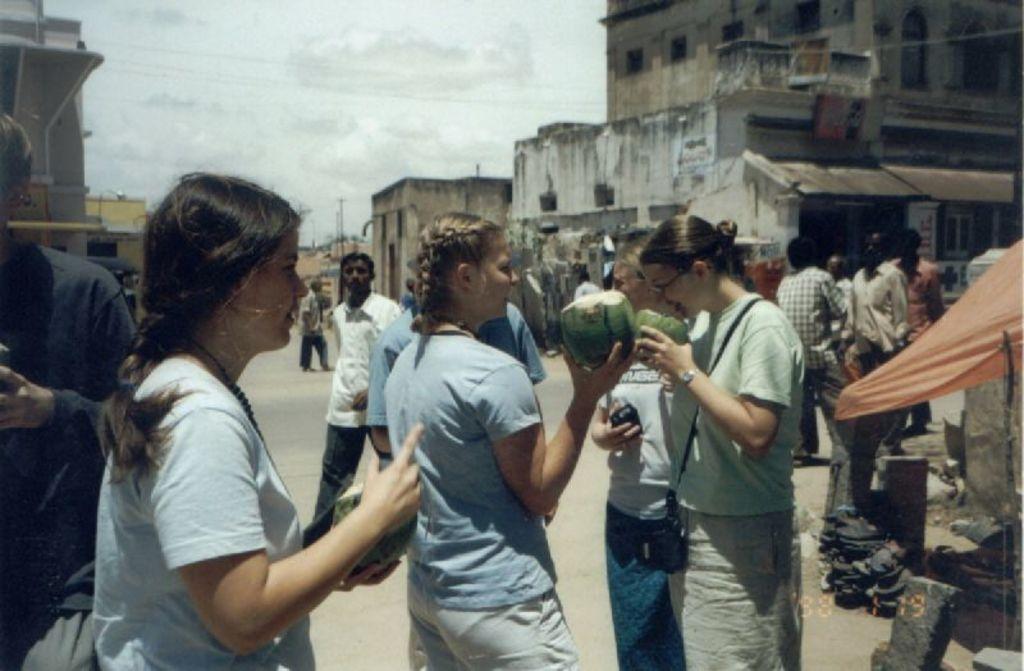In one or two sentences, can you explain what this image depicts? In this picture we can see a woman who are holding a coconut. On the right there is a woman who is wearing watch, t-shirt and trouser. On the background we can buildings, street lights, electric poles and wires. On the top we can see sky and clouds. On the left there is a man who is wearing black t-shirt and trouser. He is holding a mobile phone. 